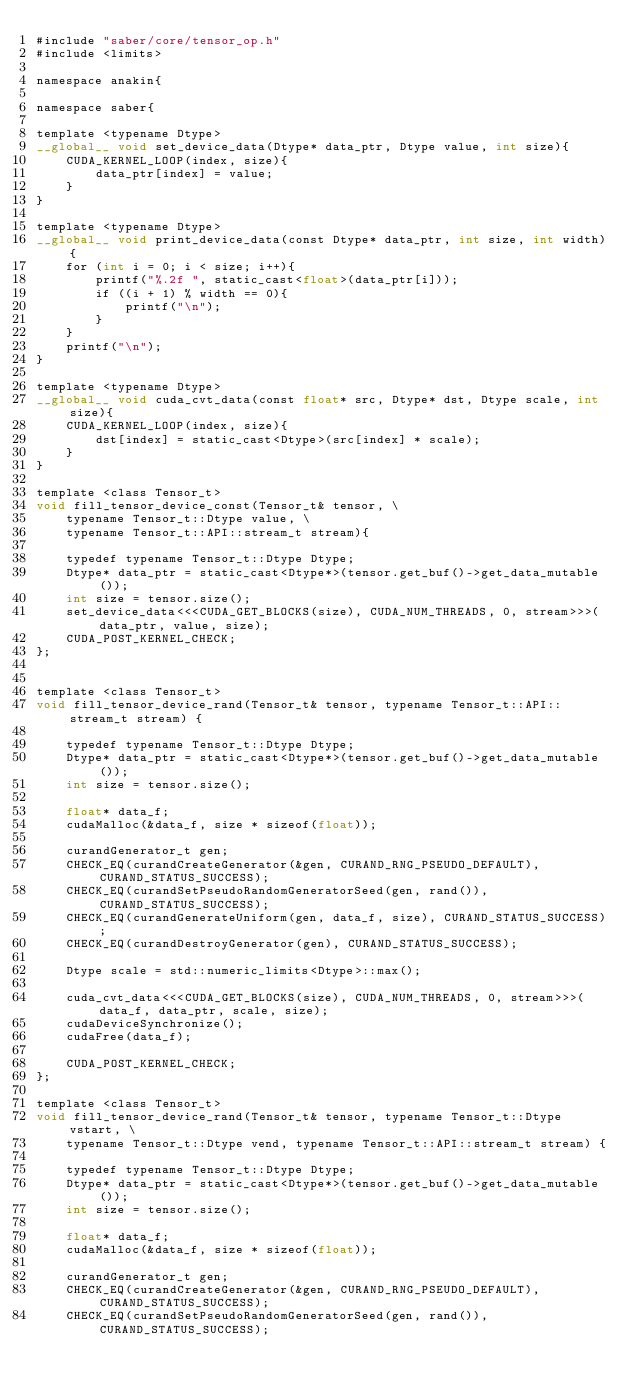<code> <loc_0><loc_0><loc_500><loc_500><_Cuda_>#include "saber/core/tensor_op.h"
#include <limits>

namespace anakin{

namespace saber{

template <typename Dtype>
__global__ void set_device_data(Dtype* data_ptr, Dtype value, int size){
    CUDA_KERNEL_LOOP(index, size){
        data_ptr[index] = value;
    }
}

template <typename Dtype>
__global__ void print_device_data(const Dtype* data_ptr, int size, int width){
    for (int i = 0; i < size; i++){
        printf("%.2f ", static_cast<float>(data_ptr[i]));
        if ((i + 1) % width == 0){
            printf("\n");
        }
    }
    printf("\n");
}

template <typename Dtype>
__global__ void cuda_cvt_data(const float* src, Dtype* dst, Dtype scale, int size){
    CUDA_KERNEL_LOOP(index, size){
        dst[index] = static_cast<Dtype>(src[index] * scale);
    }
}

template <class Tensor_t>
void fill_tensor_device_const(Tensor_t& tensor, \
    typename Tensor_t::Dtype value, \
    typename Tensor_t::API::stream_t stream){

    typedef typename Tensor_t::Dtype Dtype;
    Dtype* data_ptr = static_cast<Dtype*>(tensor.get_buf()->get_data_mutable());
    int size = tensor.size();
    set_device_data<<<CUDA_GET_BLOCKS(size), CUDA_NUM_THREADS, 0, stream>>>(data_ptr, value, size);
    CUDA_POST_KERNEL_CHECK;
};


template <class Tensor_t>
void fill_tensor_device_rand(Tensor_t& tensor, typename Tensor_t::API::stream_t stream) {

    typedef typename Tensor_t::Dtype Dtype;
    Dtype* data_ptr = static_cast<Dtype*>(tensor.get_buf()->get_data_mutable());
    int size = tensor.size();

    float* data_f;
    cudaMalloc(&data_f, size * sizeof(float));

    curandGenerator_t gen;
    CHECK_EQ(curandCreateGenerator(&gen, CURAND_RNG_PSEUDO_DEFAULT), CURAND_STATUS_SUCCESS);
    CHECK_EQ(curandSetPseudoRandomGeneratorSeed(gen, rand()), CURAND_STATUS_SUCCESS);
    CHECK_EQ(curandGenerateUniform(gen, data_f, size), CURAND_STATUS_SUCCESS);
    CHECK_EQ(curandDestroyGenerator(gen), CURAND_STATUS_SUCCESS);

    Dtype scale = std::numeric_limits<Dtype>::max();

    cuda_cvt_data<<<CUDA_GET_BLOCKS(size), CUDA_NUM_THREADS, 0, stream>>>(data_f, data_ptr, scale, size);
    cudaDeviceSynchronize();
    cudaFree(data_f);

    CUDA_POST_KERNEL_CHECK;
};

template <class Tensor_t>
void fill_tensor_device_rand(Tensor_t& tensor, typename Tensor_t::Dtype vstart, \
    typename Tensor_t::Dtype vend, typename Tensor_t::API::stream_t stream) {

    typedef typename Tensor_t::Dtype Dtype;
    Dtype* data_ptr = static_cast<Dtype*>(tensor.get_buf()->get_data_mutable());
    int size = tensor.size();

    float* data_f;
    cudaMalloc(&data_f, size * sizeof(float));

    curandGenerator_t gen;
    CHECK_EQ(curandCreateGenerator(&gen, CURAND_RNG_PSEUDO_DEFAULT), CURAND_STATUS_SUCCESS);
    CHECK_EQ(curandSetPseudoRandomGeneratorSeed(gen, rand()), CURAND_STATUS_SUCCESS);</code> 